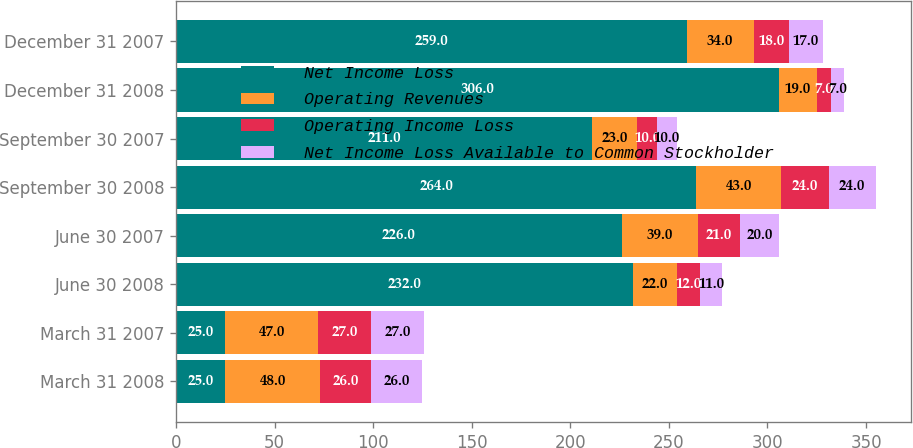Convert chart. <chart><loc_0><loc_0><loc_500><loc_500><stacked_bar_chart><ecel><fcel>March 31 2008<fcel>March 31 2007<fcel>June 30 2008<fcel>June 30 2007<fcel>September 30 2008<fcel>September 30 2007<fcel>December 31 2008<fcel>December 31 2007<nl><fcel>Net Income Loss<fcel>25<fcel>25<fcel>232<fcel>226<fcel>264<fcel>211<fcel>306<fcel>259<nl><fcel>Operating Revenues<fcel>48<fcel>47<fcel>22<fcel>39<fcel>43<fcel>23<fcel>19<fcel>34<nl><fcel>Operating Income Loss<fcel>26<fcel>27<fcel>12<fcel>21<fcel>24<fcel>10<fcel>7<fcel>18<nl><fcel>Net Income Loss Available to Common Stockholder<fcel>26<fcel>27<fcel>11<fcel>20<fcel>24<fcel>10<fcel>7<fcel>17<nl></chart> 